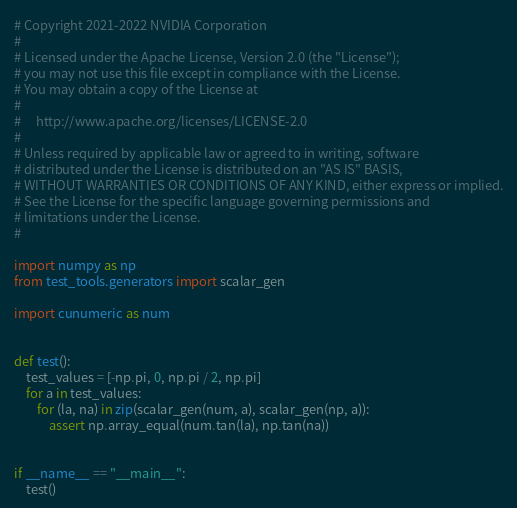<code> <loc_0><loc_0><loc_500><loc_500><_Python_># Copyright 2021-2022 NVIDIA Corporation
#
# Licensed under the Apache License, Version 2.0 (the "License");
# you may not use this file except in compliance with the License.
# You may obtain a copy of the License at
#
#     http://www.apache.org/licenses/LICENSE-2.0
#
# Unless required by applicable law or agreed to in writing, software
# distributed under the License is distributed on an "AS IS" BASIS,
# WITHOUT WARRANTIES OR CONDITIONS OF ANY KIND, either express or implied.
# See the License for the specific language governing permissions and
# limitations under the License.
#

import numpy as np
from test_tools.generators import scalar_gen

import cunumeric as num


def test():
    test_values = [-np.pi, 0, np.pi / 2, np.pi]
    for a in test_values:
        for (la, na) in zip(scalar_gen(num, a), scalar_gen(np, a)):
            assert np.array_equal(num.tan(la), np.tan(na))


if __name__ == "__main__":
    test()
</code> 